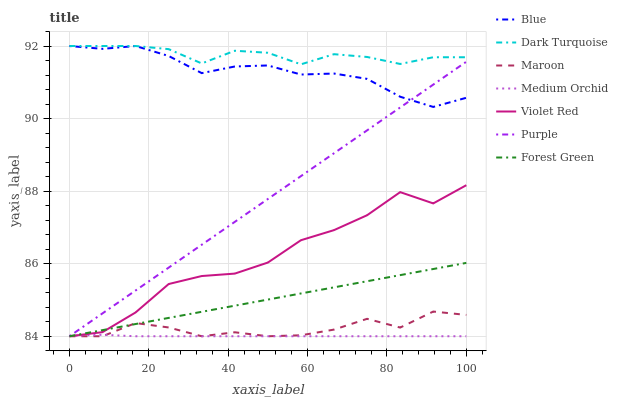Does Medium Orchid have the minimum area under the curve?
Answer yes or no. Yes. Does Dark Turquoise have the maximum area under the curve?
Answer yes or no. Yes. Does Violet Red have the minimum area under the curve?
Answer yes or no. No. Does Violet Red have the maximum area under the curve?
Answer yes or no. No. Is Purple the smoothest?
Answer yes or no. Yes. Is Violet Red the roughest?
Answer yes or no. Yes. Is Violet Red the smoothest?
Answer yes or no. No. Is Purple the roughest?
Answer yes or no. No. Does Violet Red have the lowest value?
Answer yes or no. Yes. Does Dark Turquoise have the lowest value?
Answer yes or no. No. Does Dark Turquoise have the highest value?
Answer yes or no. Yes. Does Violet Red have the highest value?
Answer yes or no. No. Is Violet Red less than Blue?
Answer yes or no. Yes. Is Dark Turquoise greater than Maroon?
Answer yes or no. Yes. Does Purple intersect Medium Orchid?
Answer yes or no. Yes. Is Purple less than Medium Orchid?
Answer yes or no. No. Is Purple greater than Medium Orchid?
Answer yes or no. No. Does Violet Red intersect Blue?
Answer yes or no. No. 